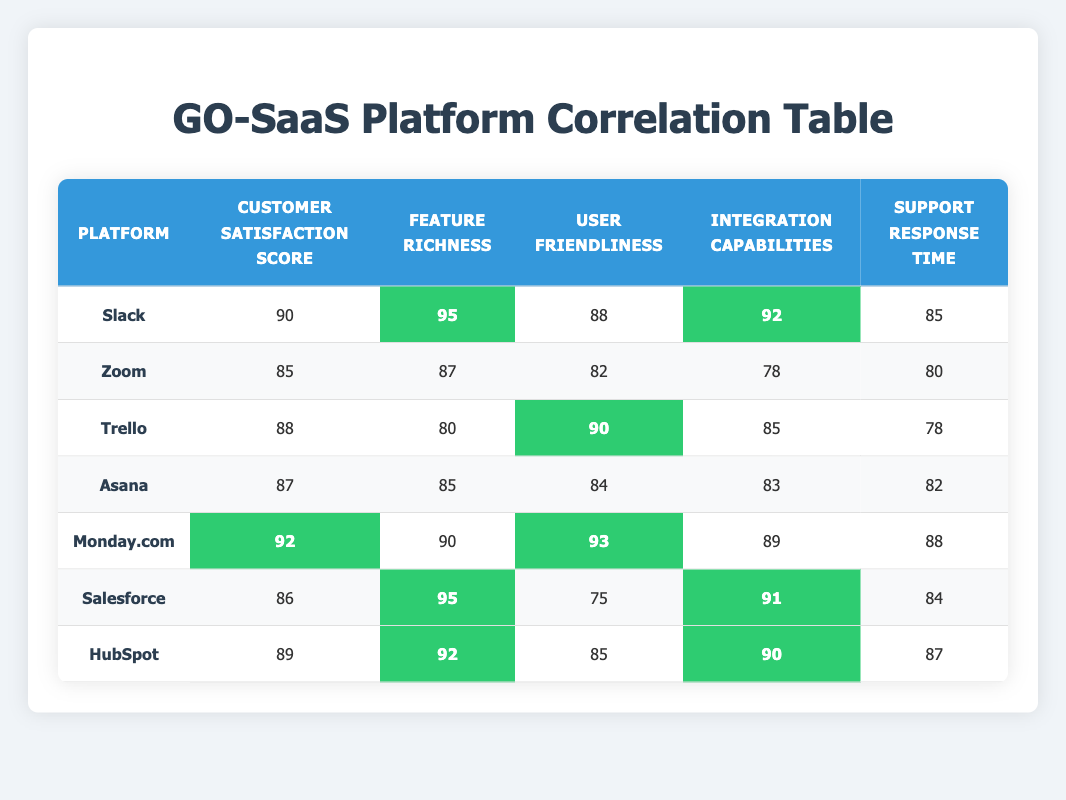What is the customer satisfaction score for Slack? The customer satisfaction score for Slack is directly listed in the table as 90.
Answer: 90 Which platform has the highest feature richness? Slack has a feature richness score of 95, which is the highest when compared to all other platforms listed.
Answer: Slack Is the customer satisfaction score for HubSpot greater than 88? HubSpot's customer satisfaction score is 89, which is greater than 88, making this statement true.
Answer: Yes What is the average customer satisfaction score of all platforms? The customer satisfaction scores are 90, 85, 88, 87, 92, 86, and 89. The sum of these scores is 517, and there are 7 platforms, so the average is 517/7 = approximately 74.14.
Answer: 74.14 Which platform has the lowest user friendliness score? Looking at the user friendliness scores, Salesforce has the lowest score of 75.
Answer: Salesforce Are there any platforms with a customer satisfaction score above 90? Yes, Monday.com has a customer satisfaction score of 92, which is above 90.
Answer: Yes What is the difference in integration capabilities between HubSpot and Zoom? HubSpot has an integration capabilities score of 90, while Zoom's score is 78. The difference is 90 - 78 = 12.
Answer: 12 Which platform has the highest support response time? Monday.com has the highest support response time of 88, which is the highest displayed in the table.
Answer: Monday.com What is the total feature richness score for all platforms? The feature richness scores are 95, 87, 80, 85, 90, 95, and 92. Adding these together (95 + 87 + 80 + 85 + 90 + 95 + 92) equals 724.
Answer: 724 